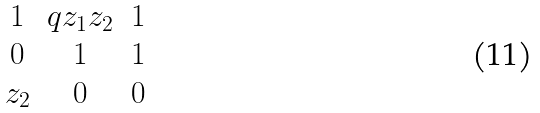Convert formula to latex. <formula><loc_0><loc_0><loc_500><loc_500>\begin{matrix} 1 & q z _ { 1 } z _ { 2 } & 1 \\ 0 & 1 & 1 \\ z _ { 2 } & 0 & 0 \end{matrix}</formula> 